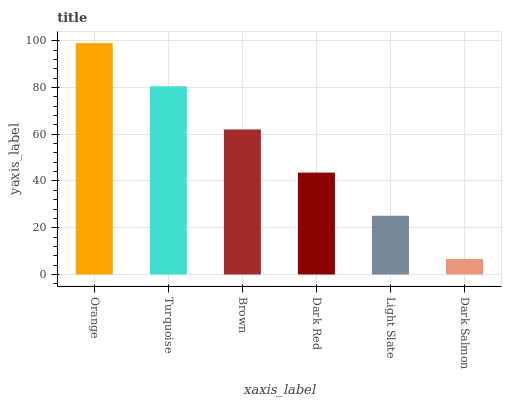Is Dark Salmon the minimum?
Answer yes or no. Yes. Is Orange the maximum?
Answer yes or no. Yes. Is Turquoise the minimum?
Answer yes or no. No. Is Turquoise the maximum?
Answer yes or no. No. Is Orange greater than Turquoise?
Answer yes or no. Yes. Is Turquoise less than Orange?
Answer yes or no. Yes. Is Turquoise greater than Orange?
Answer yes or no. No. Is Orange less than Turquoise?
Answer yes or no. No. Is Brown the high median?
Answer yes or no. Yes. Is Dark Red the low median?
Answer yes or no. Yes. Is Light Slate the high median?
Answer yes or no. No. Is Light Slate the low median?
Answer yes or no. No. 